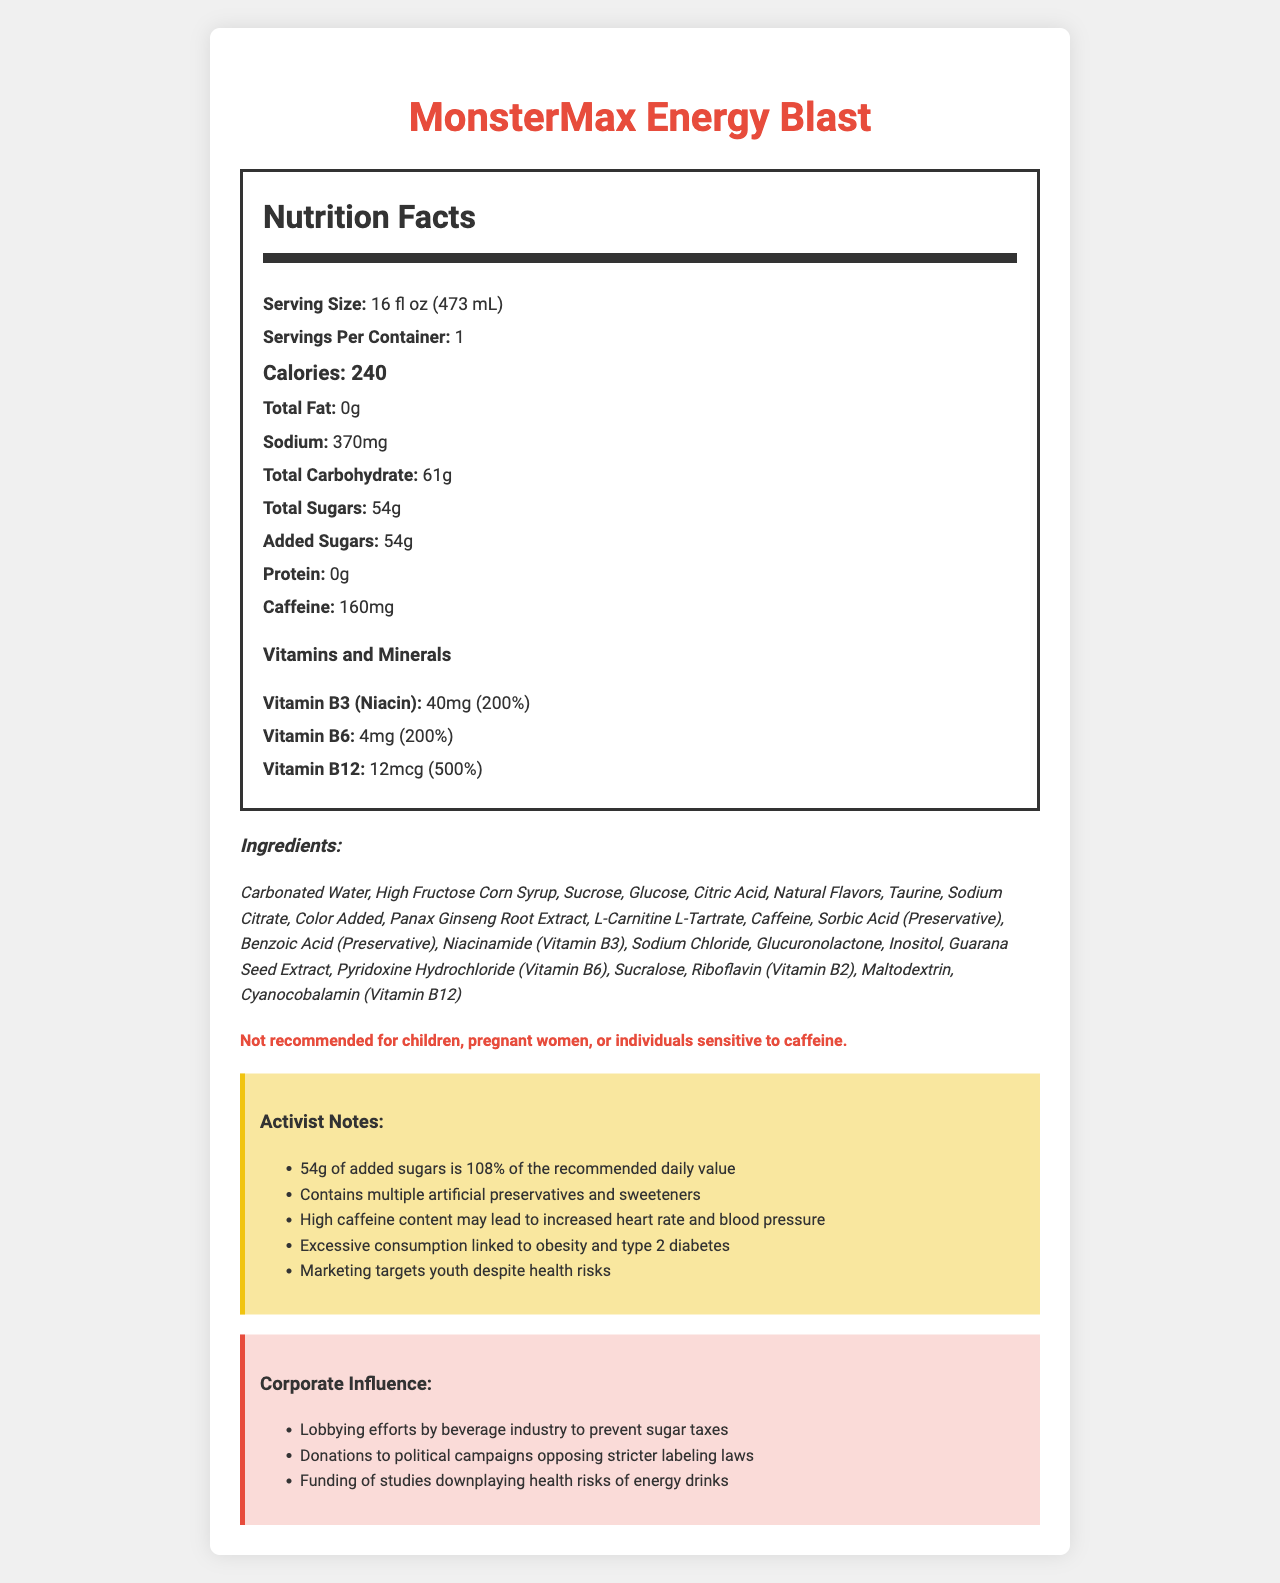what is the serving size of MonsterMax Energy Blast? The serving size is mentioned at the top of the nutrition facts section.
Answer: 16 fl oz (473 mL) how many calories are in one serving of MonsterMax Energy Blast? The calories per serving are listed prominently under the calorie section of the nutrition facts.
Answer: 240 what is the total sugar content in one serving? The document lists 'Total Sugars' as 54g in the nutrition facts label.
Answer: 54g how much caffeine is in one serving of MonsterMax Energy Blast? The caffeine content is noted in the nutrition facts section.
Answer: 160mg what percentage of the daily recommended value is the added sugars in the MonsterMax Energy Blast? According to the activist notes, 54g of added sugars is 108% of the recommended daily value.
Answer: 108% which of the following vitamins is present in the highest amount in MonsterMax Energy Blast? A. Vitamin B3 B. Vitamin B6 C. Vitamin B12 D. Vitamin A The document lists Vitamin B12 at 500% of the daily value, which is the highest among the vitamins listed.
Answer: C. Vitamin B12 how many milligrams of sodium are there in one serving of MonsterMax Energy Blast? The sodium content is listed as 370mg in the nutrition facts label.
Answer: 370mg which of these ingredients is not included in MonsterMax Energy Blast? A. Citric Acid B. Aspartame C. Guarana Seed Extract D. Natural Flavors Aspartame is not listed among the ingredients of MonsterMax Energy Blast, while the other options are.
Answer: B. Aspartame is MonsterMax Energy Blast recommended for children? There is a specific warning in the document stating it is not recommended for children.
Answer: No how many servings are there per container of MonsterMax Energy Blast? The document clearly states that there is 1 serving per container.
Answer: 1 does MonsterMax Energy Blast contain artificial preservatives? The ingredients include Sorbic Acid and Benzoic Acid, which are artificial preservatives.
Answer: Yes provide a summary of the MonsterMax Energy Blast document The document provides comprehensive details, including nutritional facts, ingredients, activist warnings about health risks, and notes on corporate influence in regulation and public perception.
Answer: The document provides nutritional information for MonsterMax Energy Blast, highlighting its high sugar content, caffeine, and artificial ingredients. It includes serving size, calorie count, vitamins, and ingredients. Warnings advise that the product is not suitable for children or pregnant women. Activist notes indicate excessive sugar and artificial preservative concerns, along with corporate influence attempting to downplay health risks and resist regulation. what is the total fat content in MonsterMax Energy Blast? The document states the total fat content as 0g in the nutrition facts section.
Answer: 0g are there any natural flavors listed in the MonsterMax Energy Blast ingredients? Natural Flavors are listed as one of the ingredients in the document.
Answer: Yes what are the corporate influences mentioned in the document regarding MonsterMax Energy Blast? The corporate influence section of the document lists these three influences.
Answer: Lobbying efforts by beverage industry to prevent sugar taxes, Donations to political campaigns opposing stricter labeling laws, Funding of studies downplaying health risks of energy drinks what is the main concern highlighted in the activist notes about sugar content in MonsterMax Energy Blast? The activist notes specifically highlight that the 54g of added sugars is 108% of the recommended daily value, indicating excessive sugar content.
Answer: 54g of added sugars is 108% of the recommended daily value 